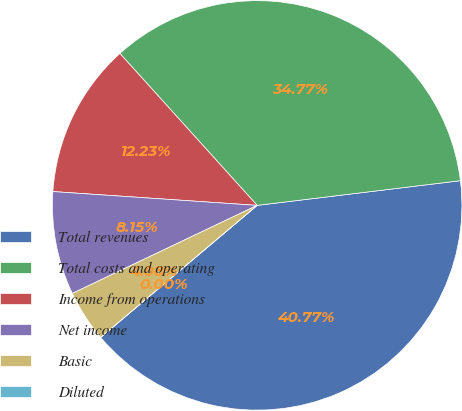Convert chart. <chart><loc_0><loc_0><loc_500><loc_500><pie_chart><fcel>Total revenues<fcel>Total costs and operating<fcel>Income from operations<fcel>Net income<fcel>Basic<fcel>Diluted<nl><fcel>40.77%<fcel>34.77%<fcel>12.23%<fcel>8.15%<fcel>4.08%<fcel>0.0%<nl></chart> 